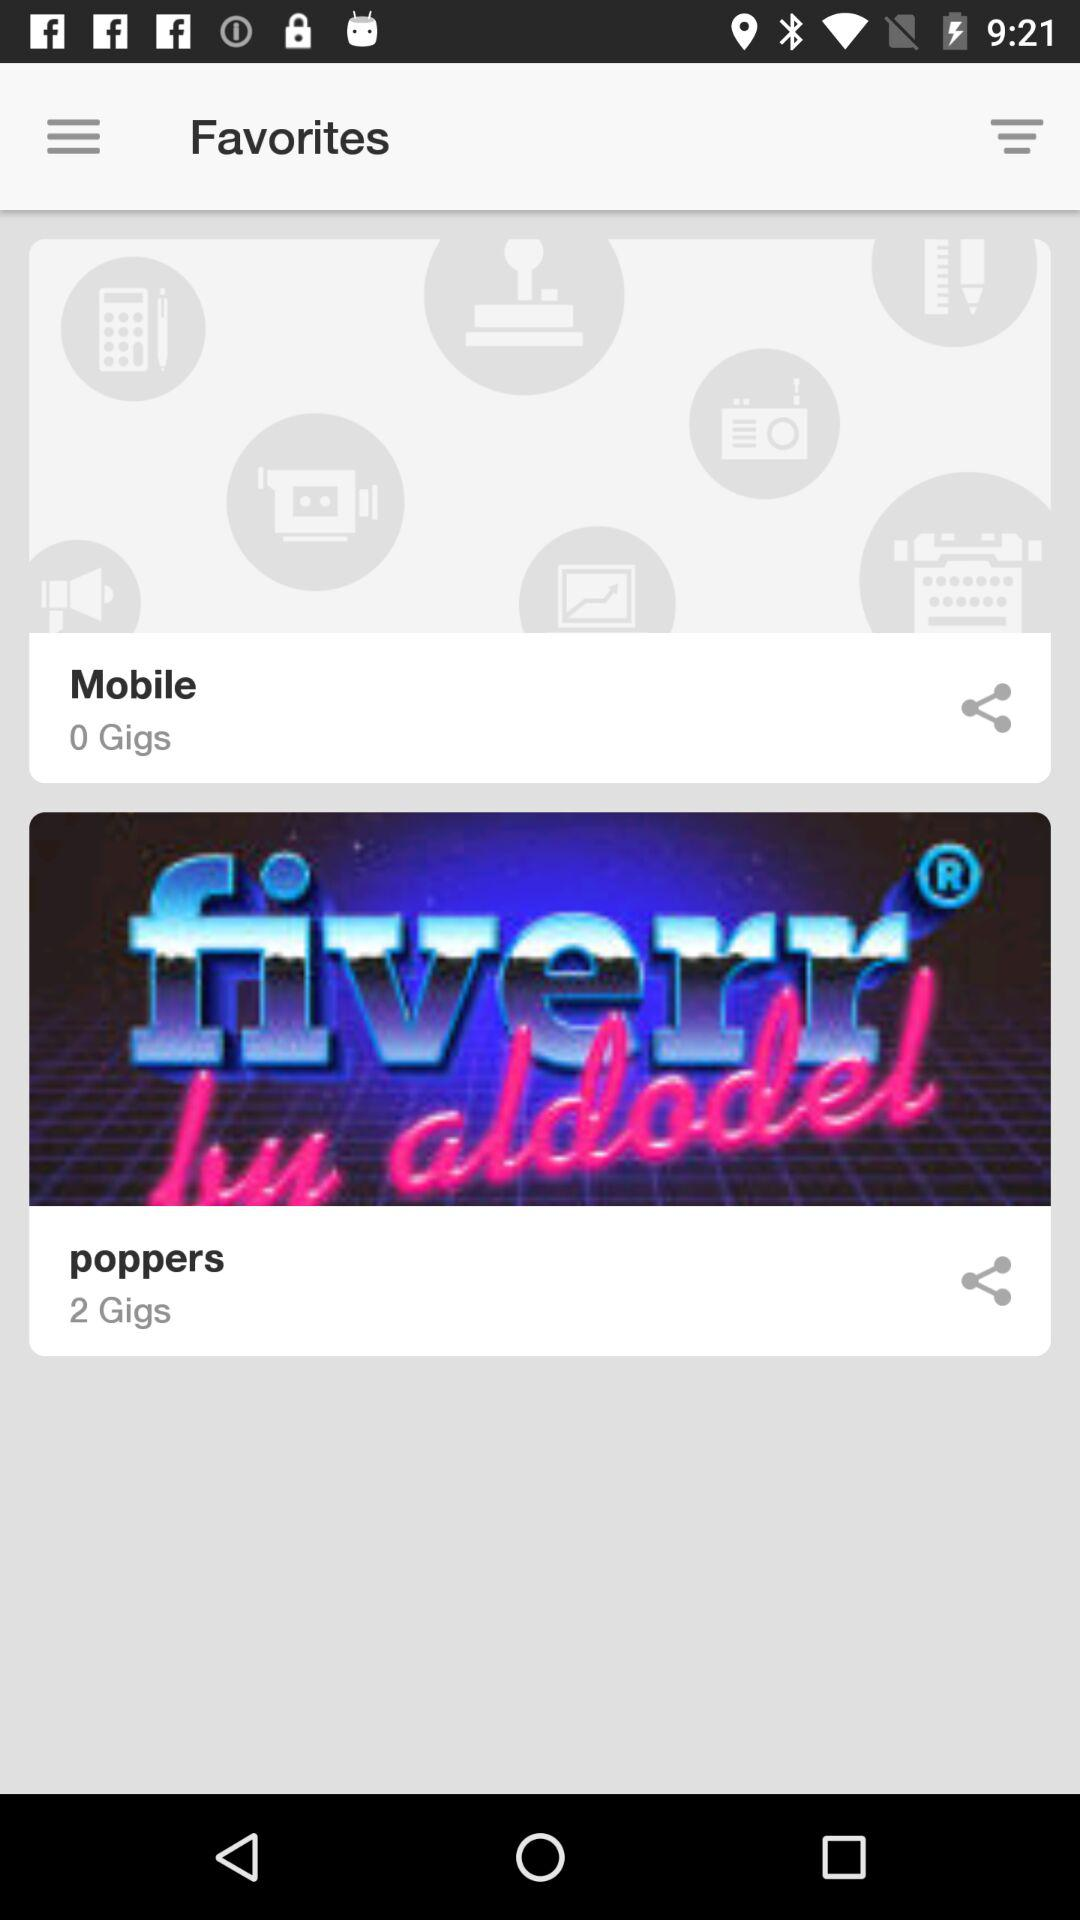How many gigs are there in "Mobile"? There are 0 gigs in "Mobile". 